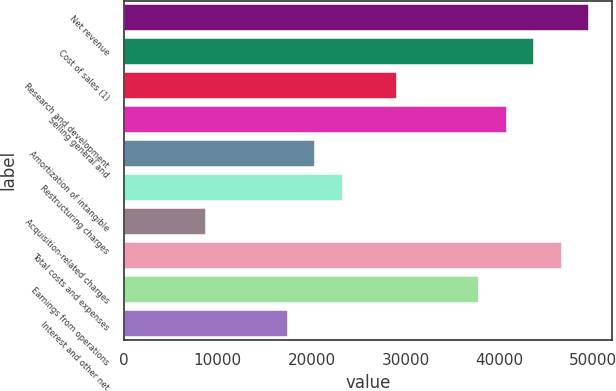<chart> <loc_0><loc_0><loc_500><loc_500><bar_chart><fcel>Net revenue<fcel>Cost of sales (1)<fcel>Research and development<fcel>Selling general and<fcel>Amortization of intangible<fcel>Restructuring charges<fcel>Acquisition-related charges<fcel>Total costs and expenses<fcel>Earnings from operations<fcel>Interest and other net<nl><fcel>49522.6<fcel>43696.4<fcel>29131<fcel>40783.3<fcel>20391.8<fcel>23304.8<fcel>8739.4<fcel>46609.5<fcel>37870.2<fcel>17478.7<nl></chart> 